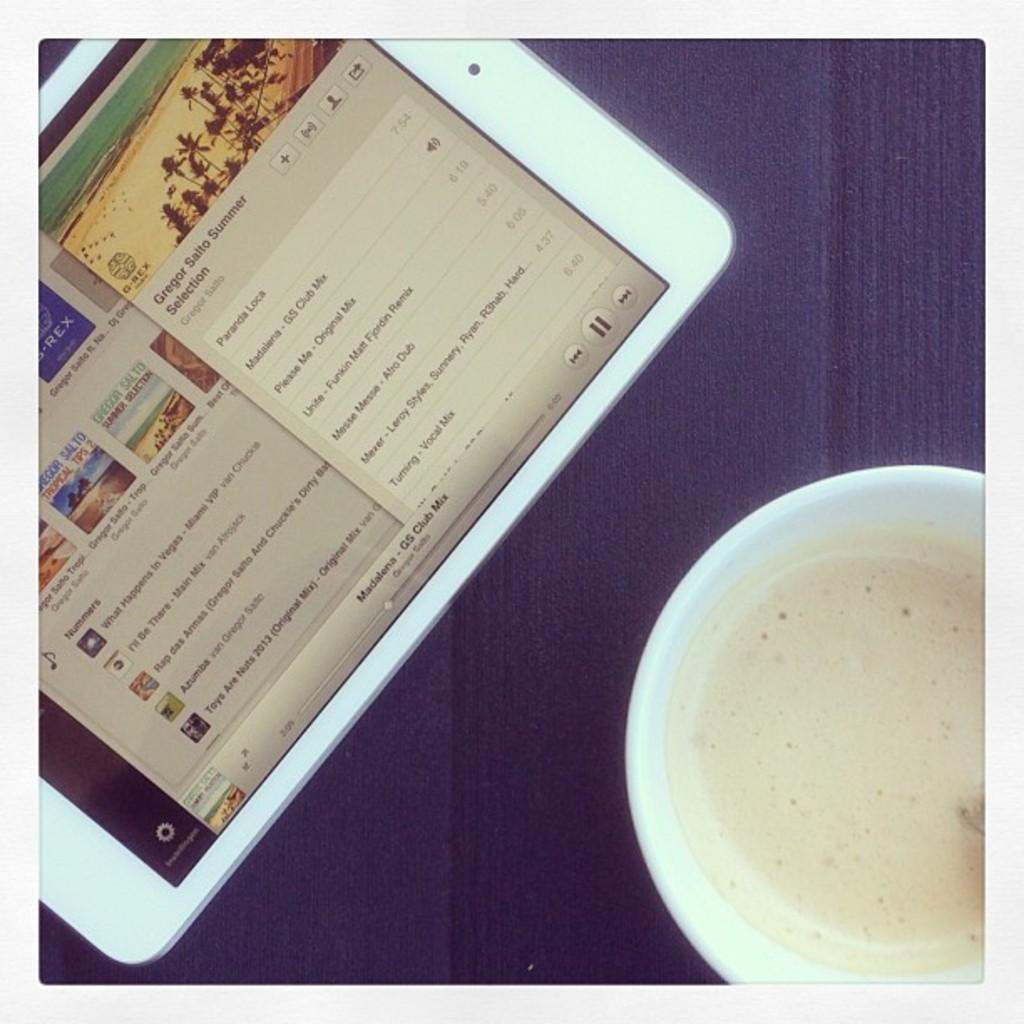Can you describe this image briefly? In this image I can see a ipad on the purple color surface and I can see a glass which is in white color. 